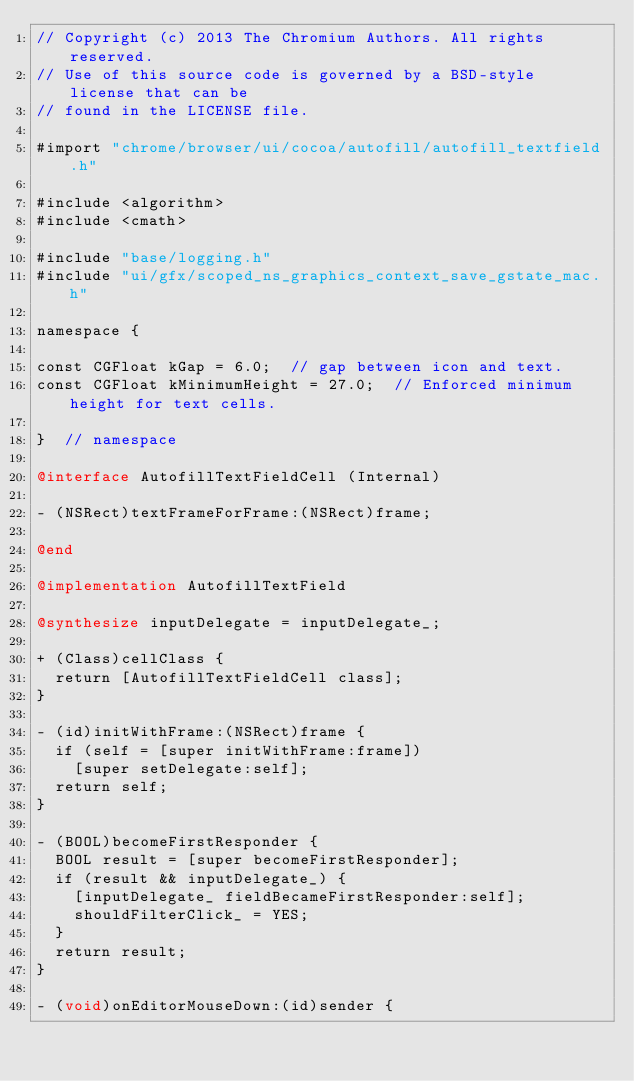<code> <loc_0><loc_0><loc_500><loc_500><_ObjectiveC_>// Copyright (c) 2013 The Chromium Authors. All rights reserved.
// Use of this source code is governed by a BSD-style license that can be
// found in the LICENSE file.

#import "chrome/browser/ui/cocoa/autofill/autofill_textfield.h"

#include <algorithm>
#include <cmath>

#include "base/logging.h"
#include "ui/gfx/scoped_ns_graphics_context_save_gstate_mac.h"

namespace {

const CGFloat kGap = 6.0;  // gap between icon and text.
const CGFloat kMinimumHeight = 27.0;  // Enforced minimum height for text cells.

}  // namespace

@interface AutofillTextFieldCell (Internal)

- (NSRect)textFrameForFrame:(NSRect)frame;

@end

@implementation AutofillTextField

@synthesize inputDelegate = inputDelegate_;

+ (Class)cellClass {
  return [AutofillTextFieldCell class];
}

- (id)initWithFrame:(NSRect)frame {
  if (self = [super initWithFrame:frame])
    [super setDelegate:self];
  return self;
}

- (BOOL)becomeFirstResponder {
  BOOL result = [super becomeFirstResponder];
  if (result && inputDelegate_) {
    [inputDelegate_ fieldBecameFirstResponder:self];
    shouldFilterClick_ = YES;
  }
  return result;
}

- (void)onEditorMouseDown:(id)sender {</code> 